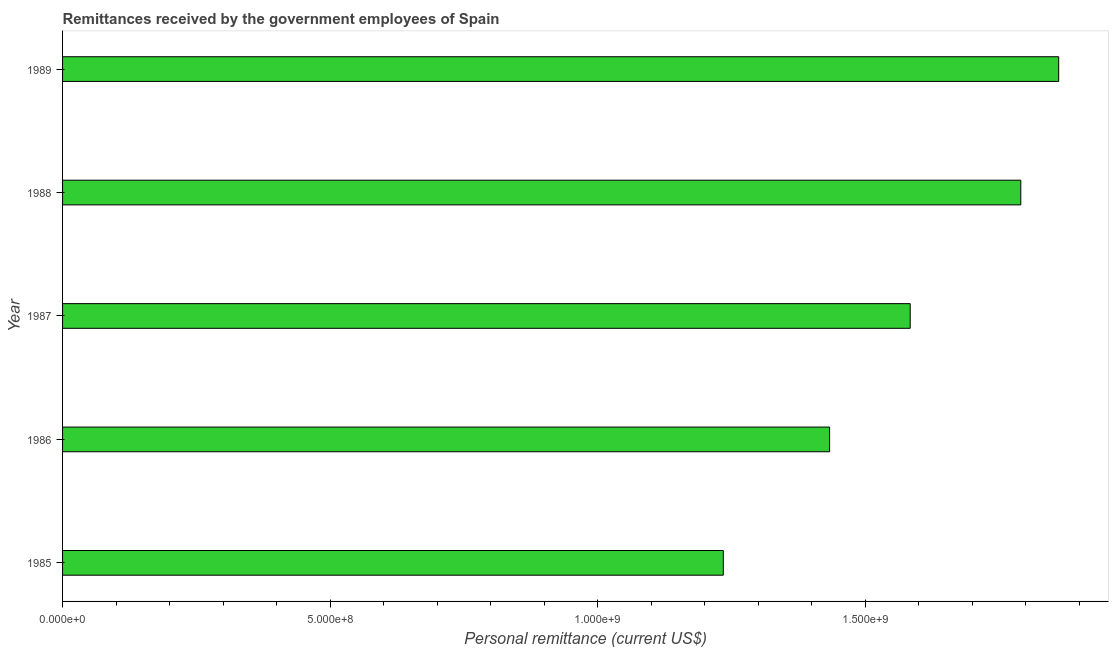What is the title of the graph?
Give a very brief answer. Remittances received by the government employees of Spain. What is the label or title of the X-axis?
Provide a short and direct response. Personal remittance (current US$). What is the label or title of the Y-axis?
Give a very brief answer. Year. What is the personal remittances in 1987?
Your answer should be very brief. 1.58e+09. Across all years, what is the maximum personal remittances?
Offer a very short reply. 1.86e+09. Across all years, what is the minimum personal remittances?
Keep it short and to the point. 1.23e+09. In which year was the personal remittances minimum?
Give a very brief answer. 1985. What is the sum of the personal remittances?
Give a very brief answer. 7.90e+09. What is the difference between the personal remittances in 1986 and 1988?
Offer a terse response. -3.57e+08. What is the average personal remittances per year?
Your answer should be very brief. 1.58e+09. What is the median personal remittances?
Provide a succinct answer. 1.58e+09. In how many years, is the personal remittances greater than 1300000000 US$?
Keep it short and to the point. 4. What is the ratio of the personal remittances in 1986 to that in 1989?
Ensure brevity in your answer.  0.77. Is the personal remittances in 1987 less than that in 1989?
Keep it short and to the point. Yes. What is the difference between the highest and the second highest personal remittances?
Your response must be concise. 7.08e+07. What is the difference between the highest and the lowest personal remittances?
Your answer should be compact. 6.27e+08. How many bars are there?
Give a very brief answer. 5. How many years are there in the graph?
Offer a very short reply. 5. Are the values on the major ticks of X-axis written in scientific E-notation?
Give a very brief answer. Yes. What is the Personal remittance (current US$) of 1985?
Provide a succinct answer. 1.23e+09. What is the Personal remittance (current US$) of 1986?
Ensure brevity in your answer.  1.43e+09. What is the Personal remittance (current US$) of 1987?
Make the answer very short. 1.58e+09. What is the Personal remittance (current US$) in 1988?
Give a very brief answer. 1.79e+09. What is the Personal remittance (current US$) of 1989?
Your answer should be very brief. 1.86e+09. What is the difference between the Personal remittance (current US$) in 1985 and 1986?
Provide a succinct answer. -1.99e+08. What is the difference between the Personal remittance (current US$) in 1985 and 1987?
Offer a very short reply. -3.49e+08. What is the difference between the Personal remittance (current US$) in 1985 and 1988?
Make the answer very short. -5.56e+08. What is the difference between the Personal remittance (current US$) in 1985 and 1989?
Make the answer very short. -6.27e+08. What is the difference between the Personal remittance (current US$) in 1986 and 1987?
Provide a succinct answer. -1.51e+08. What is the difference between the Personal remittance (current US$) in 1986 and 1988?
Keep it short and to the point. -3.57e+08. What is the difference between the Personal remittance (current US$) in 1986 and 1989?
Provide a succinct answer. -4.28e+08. What is the difference between the Personal remittance (current US$) in 1987 and 1988?
Offer a terse response. -2.07e+08. What is the difference between the Personal remittance (current US$) in 1987 and 1989?
Provide a succinct answer. -2.77e+08. What is the difference between the Personal remittance (current US$) in 1988 and 1989?
Ensure brevity in your answer.  -7.08e+07. What is the ratio of the Personal remittance (current US$) in 1985 to that in 1986?
Provide a succinct answer. 0.86. What is the ratio of the Personal remittance (current US$) in 1985 to that in 1987?
Offer a very short reply. 0.78. What is the ratio of the Personal remittance (current US$) in 1985 to that in 1988?
Your response must be concise. 0.69. What is the ratio of the Personal remittance (current US$) in 1985 to that in 1989?
Give a very brief answer. 0.66. What is the ratio of the Personal remittance (current US$) in 1986 to that in 1987?
Your response must be concise. 0.91. What is the ratio of the Personal remittance (current US$) in 1986 to that in 1988?
Your response must be concise. 0.8. What is the ratio of the Personal remittance (current US$) in 1986 to that in 1989?
Offer a very short reply. 0.77. What is the ratio of the Personal remittance (current US$) in 1987 to that in 1988?
Ensure brevity in your answer.  0.89. What is the ratio of the Personal remittance (current US$) in 1987 to that in 1989?
Offer a very short reply. 0.85. What is the ratio of the Personal remittance (current US$) in 1988 to that in 1989?
Offer a terse response. 0.96. 